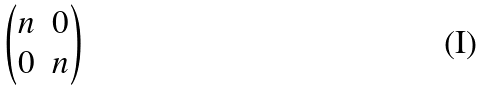Convert formula to latex. <formula><loc_0><loc_0><loc_500><loc_500>\begin{pmatrix} n & 0 \\ 0 & n \end{pmatrix}</formula> 